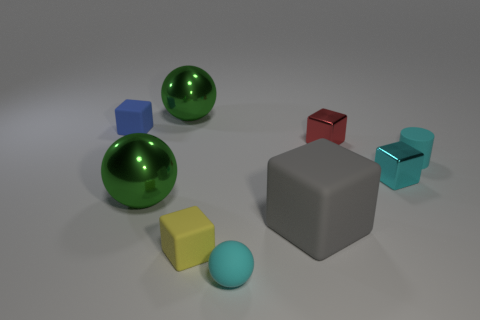What materials appear to be represented by the objects? The objects in the image seem to be made of different types of materials. The green spheres have a shiny, reflective surface that could represent polished metal or glass, while the cube in the center has a matte finish that might suggest a stone or concrete material. The other objects have colors that could represent different types of painted or colored plastics or metals. 